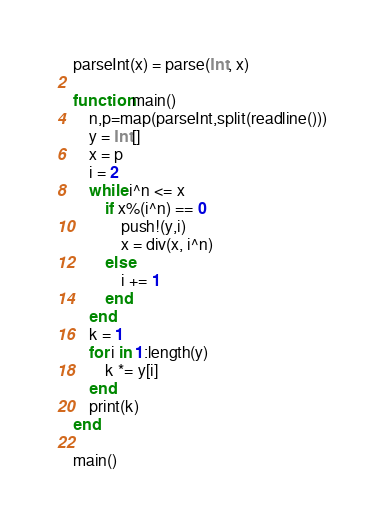<code> <loc_0><loc_0><loc_500><loc_500><_Julia_>parseInt(x) = parse(Int, x)

function main()
	n,p=map(parseInt,split(readline()))
	y = Int[]
	x = p
	i = 2
	while i^n <= x
		if x%(i^n) == 0
			push!(y,i)
			x = div(x, i^n)
		else
			i += 1
		end
	end
	k = 1
	for i in 1:length(y)
		k *= y[i]
	end
	print(k)
end

main()</code> 